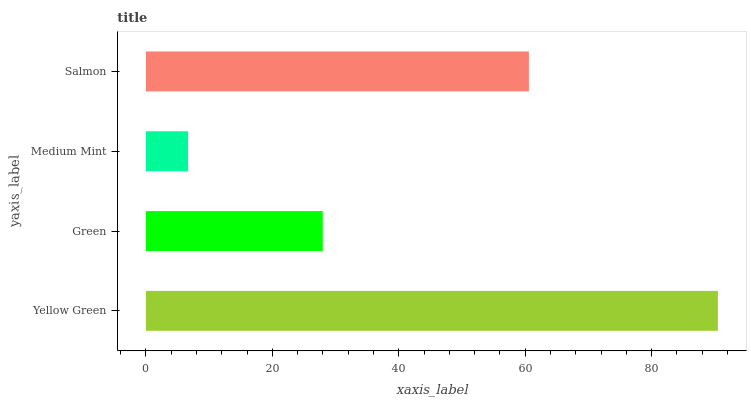Is Medium Mint the minimum?
Answer yes or no. Yes. Is Yellow Green the maximum?
Answer yes or no. Yes. Is Green the minimum?
Answer yes or no. No. Is Green the maximum?
Answer yes or no. No. Is Yellow Green greater than Green?
Answer yes or no. Yes. Is Green less than Yellow Green?
Answer yes or no. Yes. Is Green greater than Yellow Green?
Answer yes or no. No. Is Yellow Green less than Green?
Answer yes or no. No. Is Salmon the high median?
Answer yes or no. Yes. Is Green the low median?
Answer yes or no. Yes. Is Yellow Green the high median?
Answer yes or no. No. Is Medium Mint the low median?
Answer yes or no. No. 